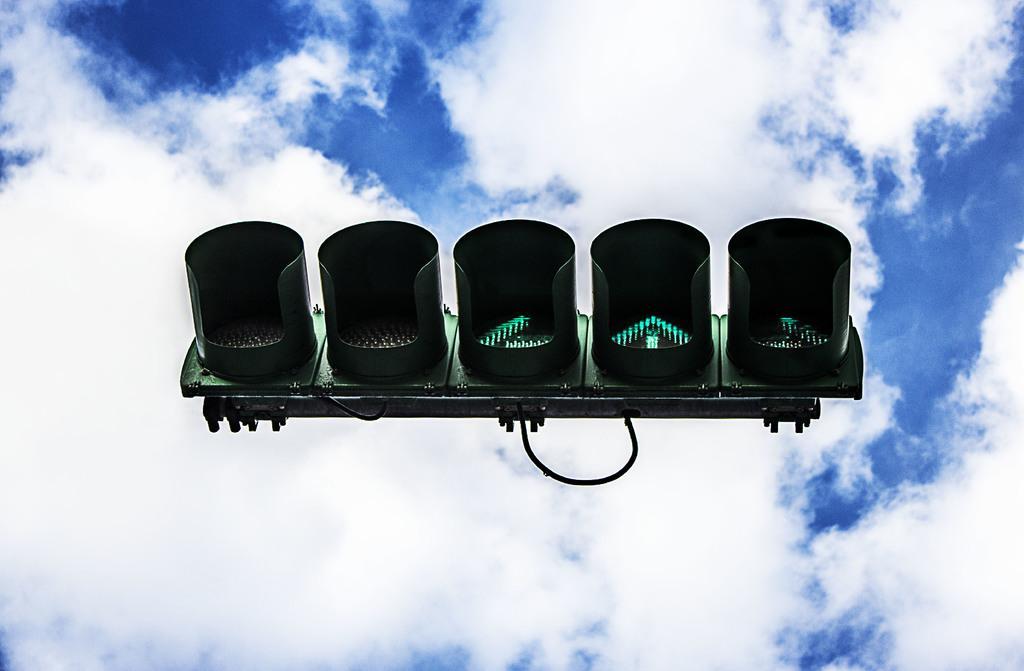How would you summarize this image in a sentence or two? In this image there is a signal board in the sky. 